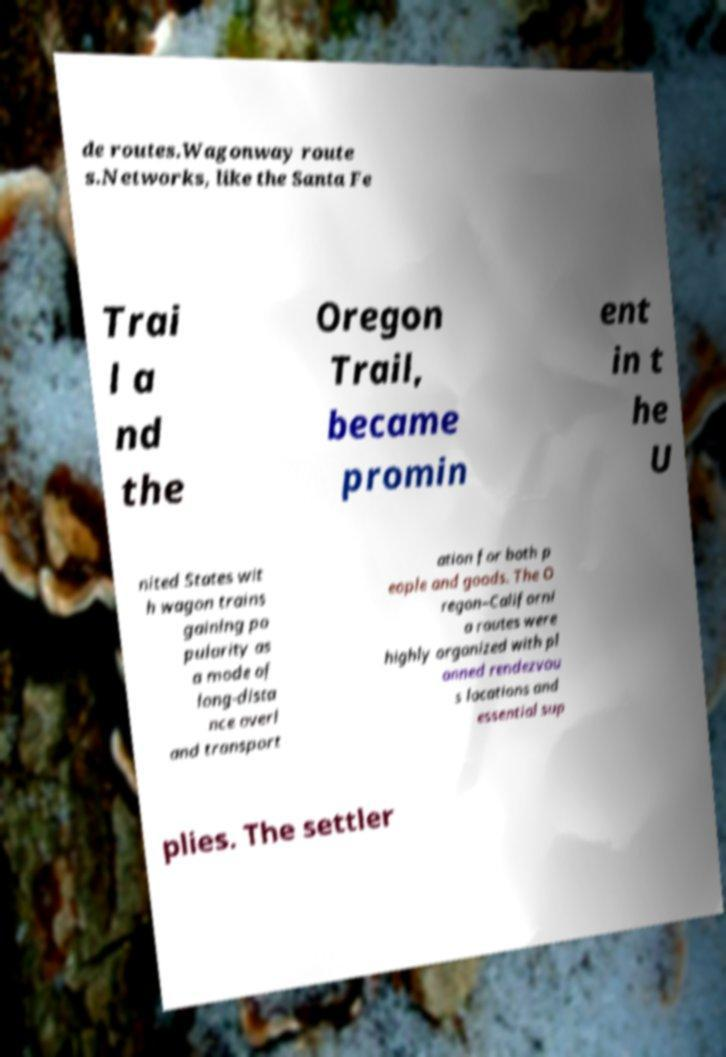For documentation purposes, I need the text within this image transcribed. Could you provide that? de routes.Wagonway route s.Networks, like the Santa Fe Trai l a nd the Oregon Trail, became promin ent in t he U nited States wit h wagon trains gaining po pularity as a mode of long-dista nce overl and transport ation for both p eople and goods. The O regon–Californi a routes were highly organized with pl anned rendezvou s locations and essential sup plies. The settler 